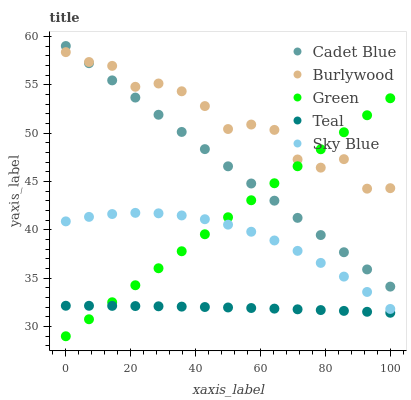Does Teal have the minimum area under the curve?
Answer yes or no. Yes. Does Burlywood have the maximum area under the curve?
Answer yes or no. Yes. Does Sky Blue have the minimum area under the curve?
Answer yes or no. No. Does Sky Blue have the maximum area under the curve?
Answer yes or no. No. Is Cadet Blue the smoothest?
Answer yes or no. Yes. Is Burlywood the roughest?
Answer yes or no. Yes. Is Sky Blue the smoothest?
Answer yes or no. No. Is Sky Blue the roughest?
Answer yes or no. No. Does Green have the lowest value?
Answer yes or no. Yes. Does Sky Blue have the lowest value?
Answer yes or no. No. Does Cadet Blue have the highest value?
Answer yes or no. Yes. Does Sky Blue have the highest value?
Answer yes or no. No. Is Sky Blue less than Cadet Blue?
Answer yes or no. Yes. Is Cadet Blue greater than Sky Blue?
Answer yes or no. Yes. Does Burlywood intersect Cadet Blue?
Answer yes or no. Yes. Is Burlywood less than Cadet Blue?
Answer yes or no. No. Is Burlywood greater than Cadet Blue?
Answer yes or no. No. Does Sky Blue intersect Cadet Blue?
Answer yes or no. No. 